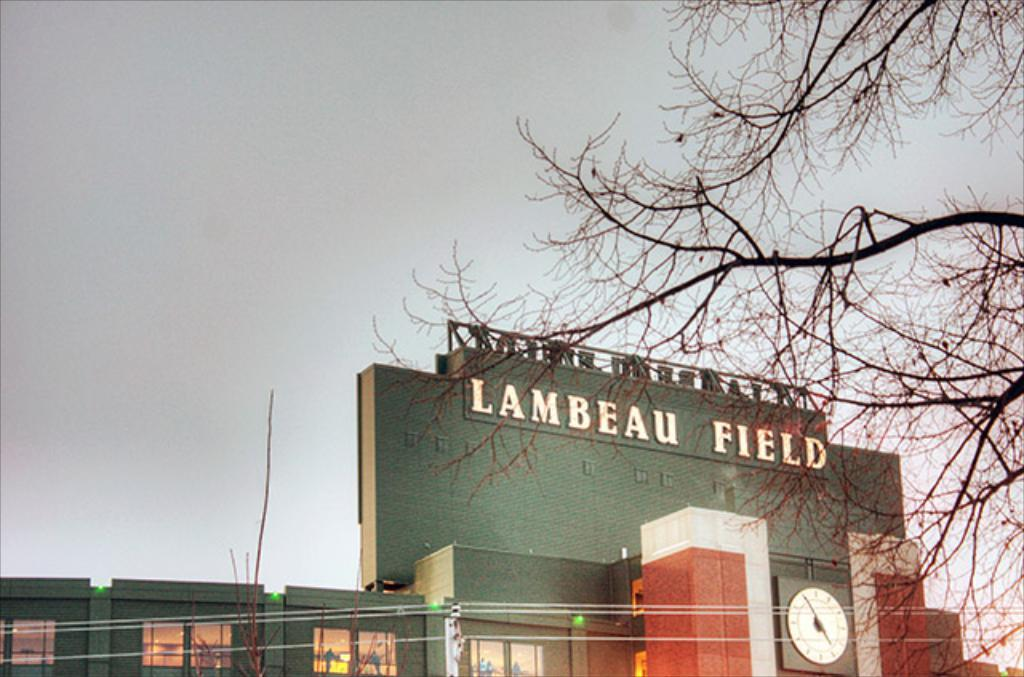What type of structure is in the image? There is a building in the image. What can be seen on the building? The building has some text on it. What can be seen illuminated in the image? There are lights visible in the image. What architectural features are present on the building? The building has windows. What time-related object is in the image? There is a clock in the image. What type of vegetation is present in the image? Trees are present in the image. What part of the natural environment is visible in the image? The sky is visible in the image. What type of calculator is being used to measure the distance between the trees in the image? There is no calculator present in the image, and no measurement of distance between trees is depicted. 